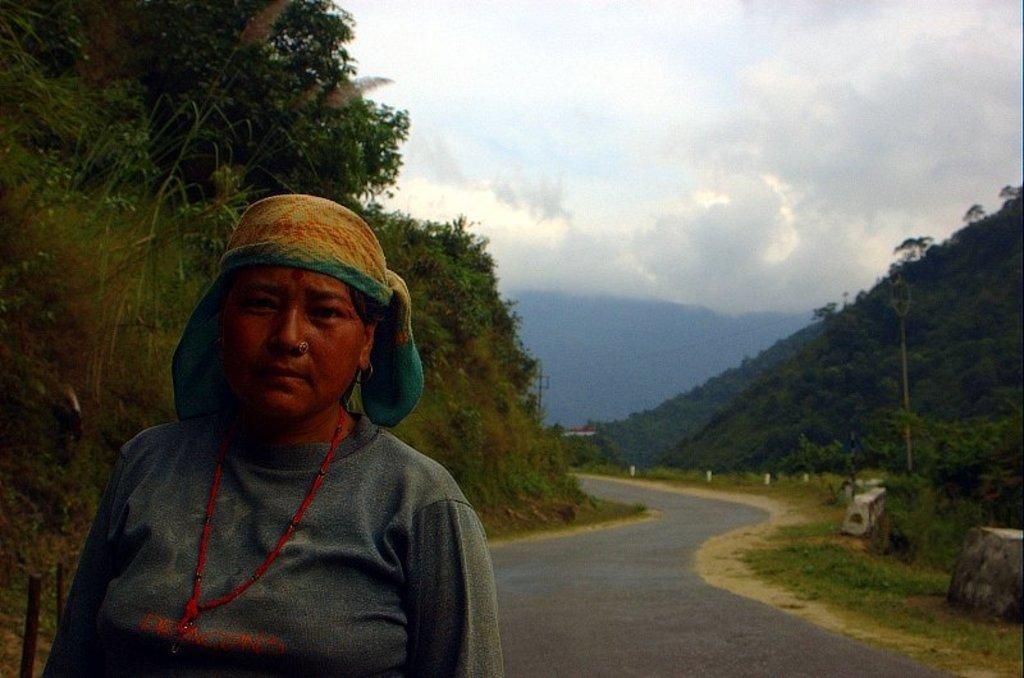Could you give a brief overview of what you see in this image? In this image we can see few hills. There are many trees and plants in the image. There is a road and a lady in the image. There are road edge markers in the image. There is a cloudy sky in the image. 